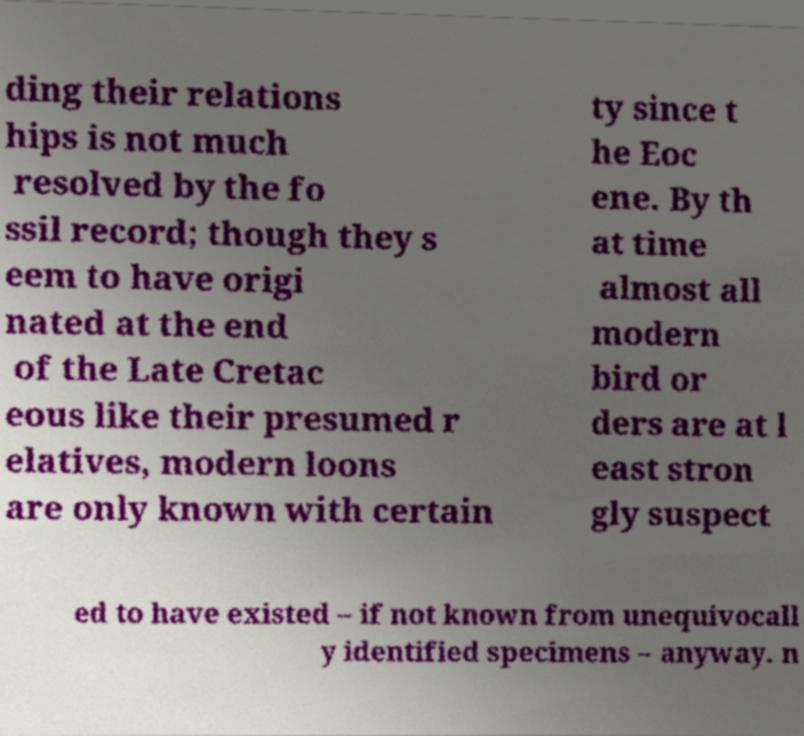Please read and relay the text visible in this image. What does it say? ding their relations hips is not much resolved by the fo ssil record; though they s eem to have origi nated at the end of the Late Cretac eous like their presumed r elatives, modern loons are only known with certain ty since t he Eoc ene. By th at time almost all modern bird or ders are at l east stron gly suspect ed to have existed – if not known from unequivocall y identified specimens – anyway. n 